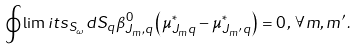Convert formula to latex. <formula><loc_0><loc_0><loc_500><loc_500>\oint \lim i t s _ { S _ { \omega } } { d S _ { q } \beta _ { J _ { m } , q } ^ { 0 } \left ( { \mu _ { J _ { m } q } ^ { * } - \mu _ { J _ { m ^ { \prime } } q } ^ { * } } \right ) } = 0 \, , \, \forall m , m ^ { \prime } \, .</formula> 